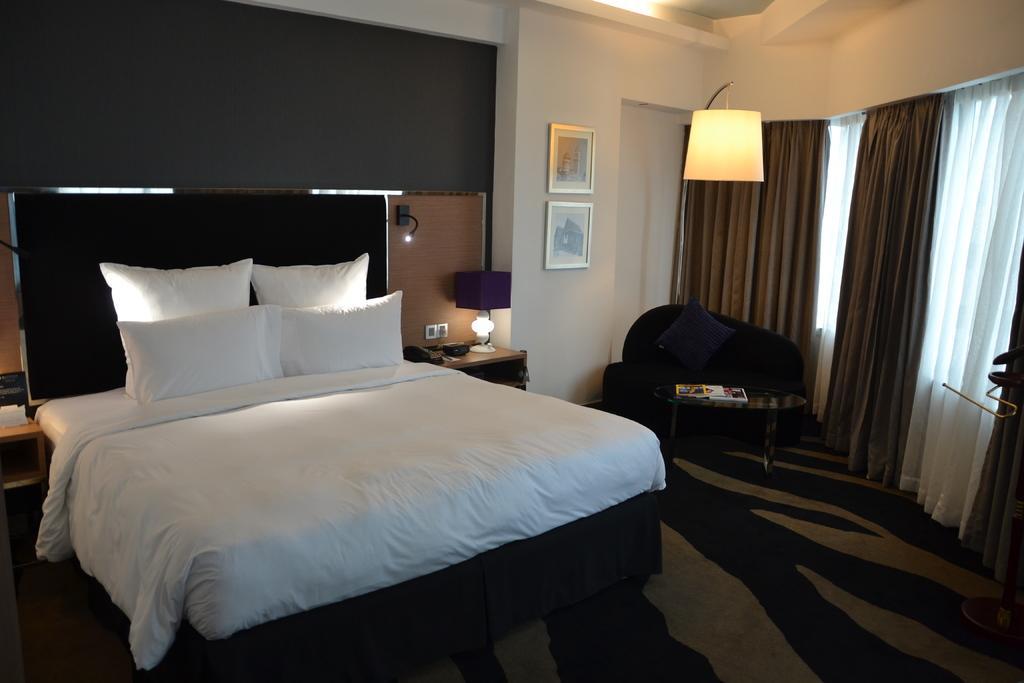Can you describe this image briefly? in the picture we can see the bed,on bed one bed sheet with four pillows. And on the right side we can see some curtains they were in brown color and white color. And in the center we can see the couch. And back of couch we can see the wall with photo frames. And beside the bed there is a table on the table there is a lamp. 